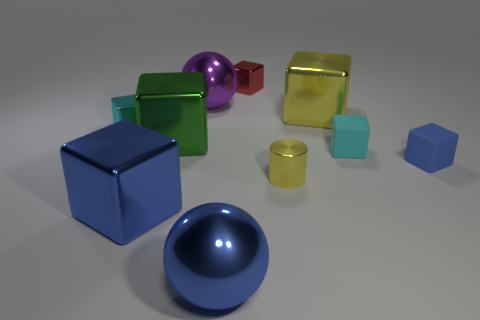How many matte objects are either red objects or big blue cubes?
Your response must be concise. 0. There is a small metal object that is in front of the cyan metallic block; is its color the same as the ball that is in front of the cylinder?
Make the answer very short. No. Is there anything else that has the same material as the big green cube?
Keep it short and to the point. Yes. The blue matte thing that is the same shape as the small cyan metal thing is what size?
Your answer should be compact. Small. Is the number of metal blocks that are in front of the tiny cyan metal thing greater than the number of tiny cyan objects?
Keep it short and to the point. No. Does the large thing that is on the right side of the small red shiny object have the same material as the small red thing?
Your response must be concise. Yes. What is the size of the block in front of the blue block that is to the right of the tiny cyan block to the right of the tiny yellow cylinder?
Make the answer very short. Large. What size is the cyan object that is the same material as the red thing?
Provide a short and direct response. Small. There is a tiny metallic thing that is right of the large blue metallic ball and behind the yellow cylinder; what color is it?
Offer a very short reply. Red. There is a yellow object that is behind the small blue matte thing; is its shape the same as the rubber object left of the blue matte block?
Provide a short and direct response. Yes. 